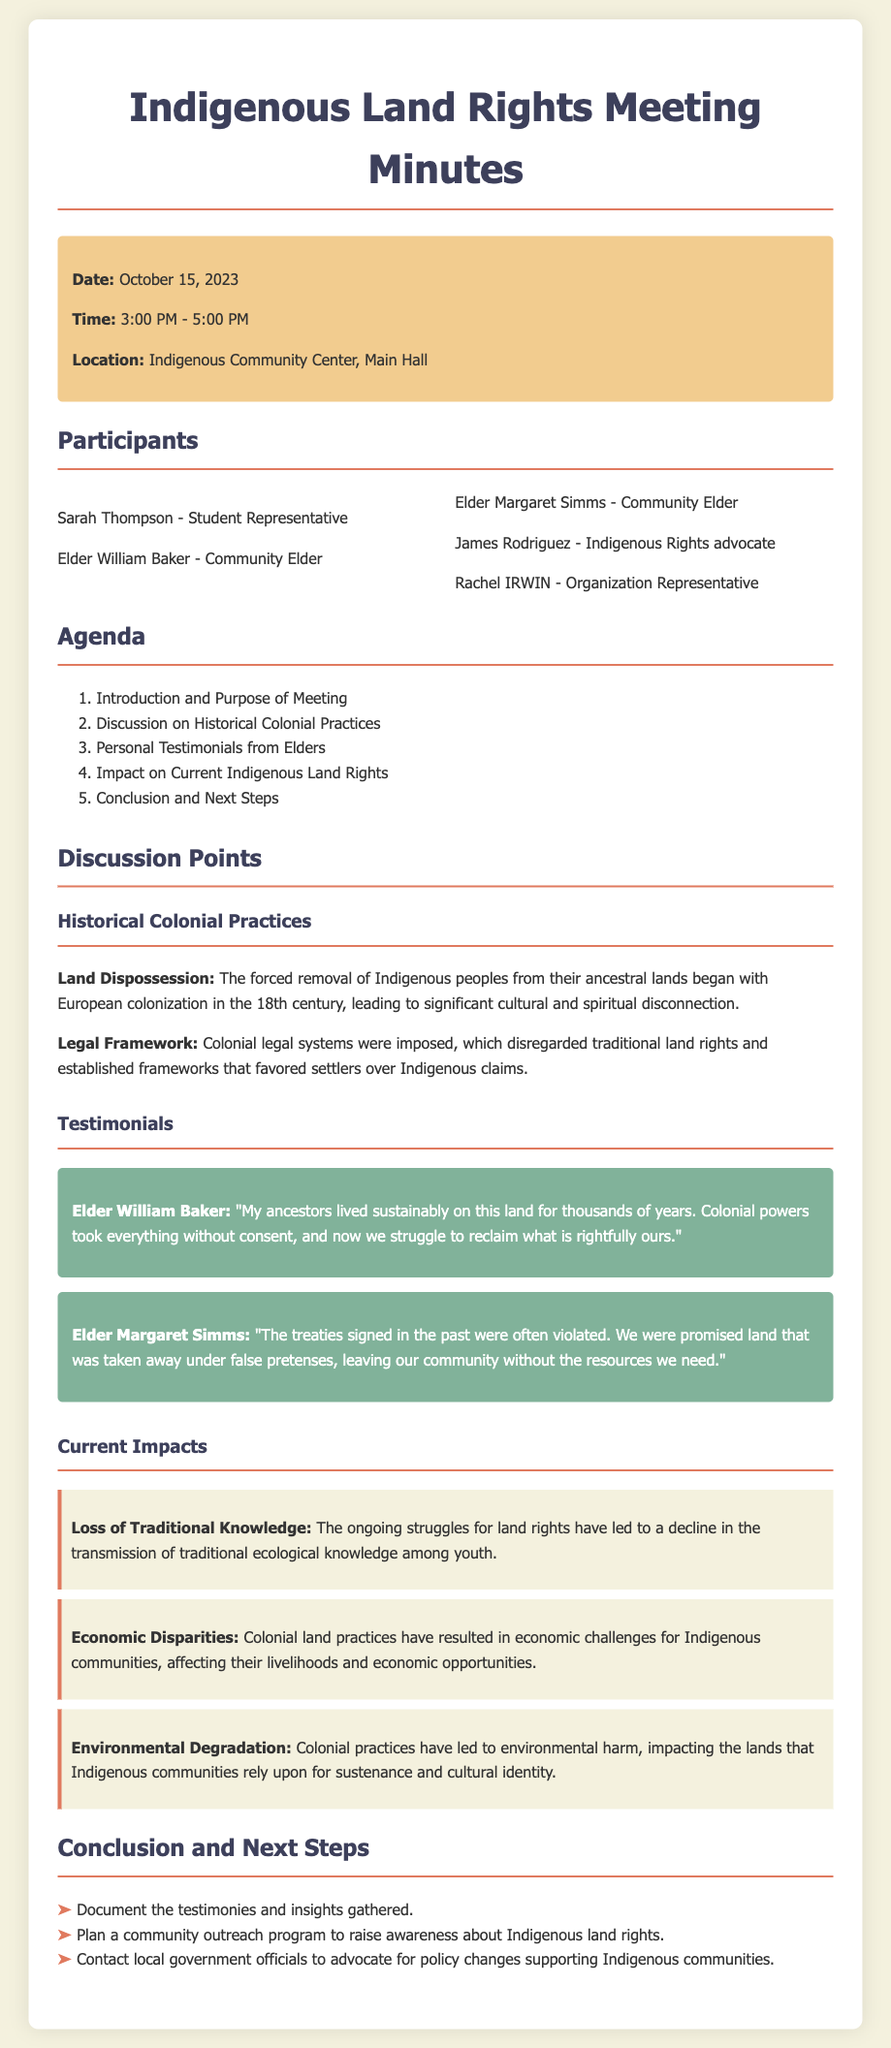What is the date of the meeting? The date of the meeting is explicitly stated in the document as October 15, 2023.
Answer: October 15, 2023 Who is one of the community elders present at the meeting? The document lists Elder William Baker and Elder Margaret Simms as community elders who participated in the meeting.
Answer: Elder William Baker What was a major topic discussed related to colonial practices? The document notes that the discussion included Land Dispossession and Legal Framework as major issues related to historical colonial practices.
Answer: Land Dispossession What impact does the document mention related to economic disparities? The ongoing struggles for land rights have led to economic challenges for Indigenous communities, according to the document.
Answer: Economic challenges What step is planned to raise awareness about Indigenous land rights? The meeting minutes outline a plan to establish a community outreach program to raise awareness about Indigenous land rights.
Answer: Community outreach program 